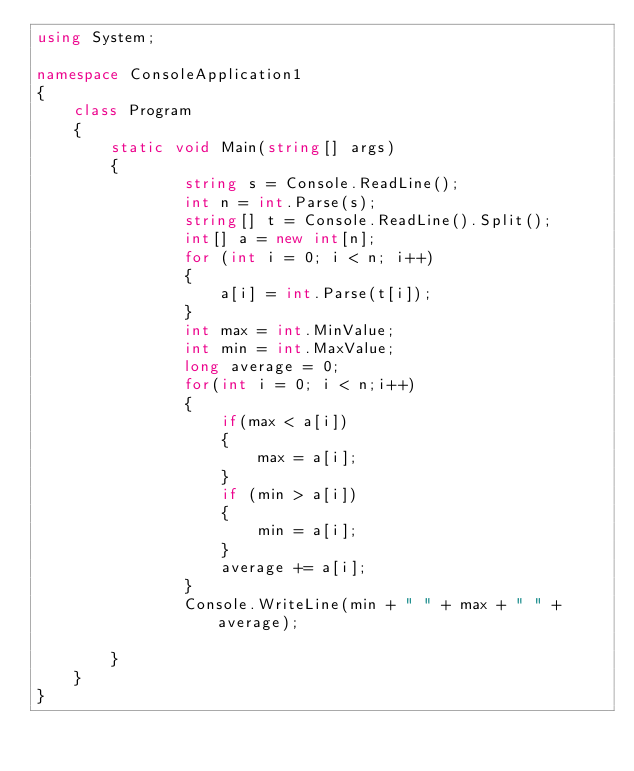<code> <loc_0><loc_0><loc_500><loc_500><_C#_>using System;

namespace ConsoleApplication1
{
    class Program
    {
        static void Main(string[] args)
        {
                string s = Console.ReadLine();
                int n = int.Parse(s);
                string[] t = Console.ReadLine().Split();
                int[] a = new int[n];
                for (int i = 0; i < n; i++)
                {
                    a[i] = int.Parse(t[i]);
                }
                int max = int.MinValue;
                int min = int.MaxValue;
                long average = 0;
                for(int i = 0; i < n;i++)
                {
                    if(max < a[i])
                    {
                        max = a[i];
                    }
                    if (min > a[i])
                    {
                        min = a[i];
                    }
                    average += a[i];
                }
                Console.WriteLine(min + " " + max + " " + average);
       
        }
    }
}</code> 